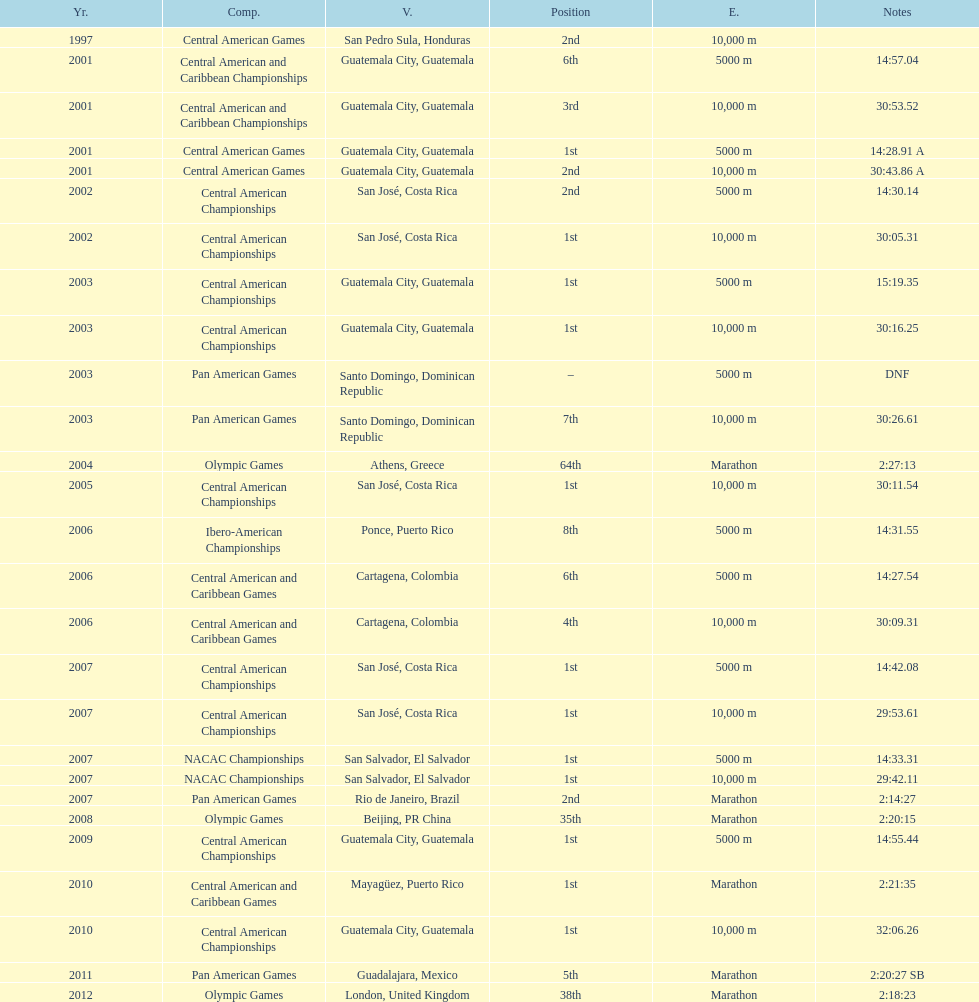How many times has this athlete not finished in a competition? 1. 